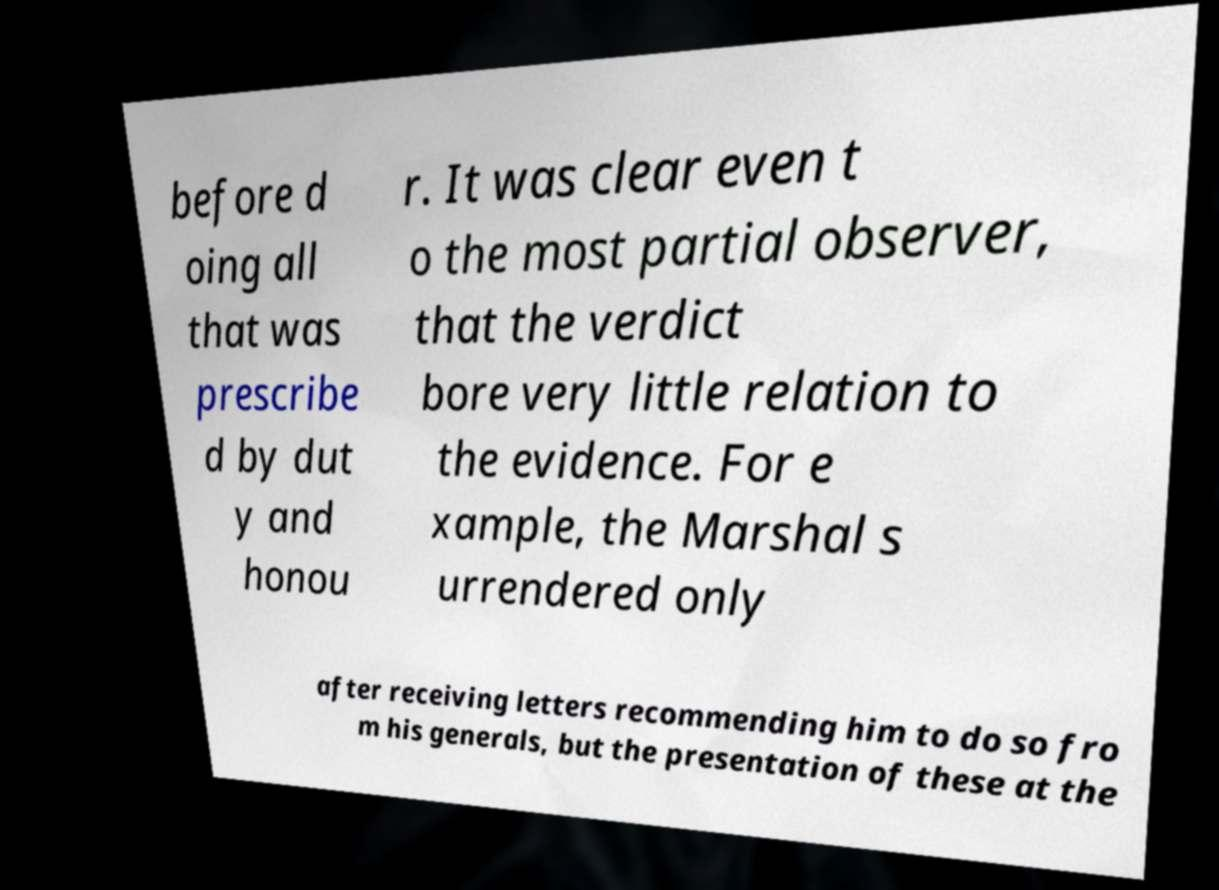I need the written content from this picture converted into text. Can you do that? before d oing all that was prescribe d by dut y and honou r. It was clear even t o the most partial observer, that the verdict bore very little relation to the evidence. For e xample, the Marshal s urrendered only after receiving letters recommending him to do so fro m his generals, but the presentation of these at the 